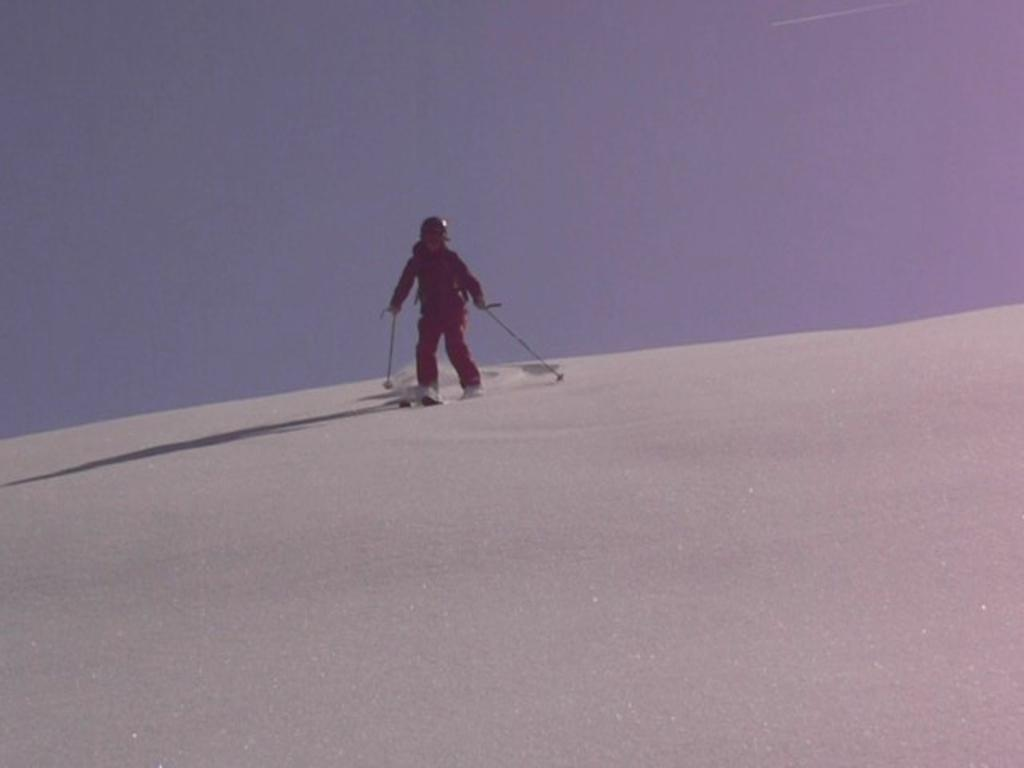What is the main subject of the image? There is a person in the image. What activity is the person engaged in? The person is skating on the surface of snow. What color is the dress the person is wearing? The person is wearing a red dress. What protective gear is the person wearing? The person is wearing a helmet. What type of detail can be seen on the person's maid uniform in the image? There is no mention of a maid uniform in the image, and the person is wearing a red dress and a helmet. 